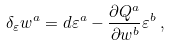Convert formula to latex. <formula><loc_0><loc_0><loc_500><loc_500>\delta _ { \varepsilon } w ^ { a } = d \varepsilon ^ { a } - \frac { \partial Q ^ { a } } { \partial w ^ { b } } \varepsilon ^ { b } \, ,</formula> 